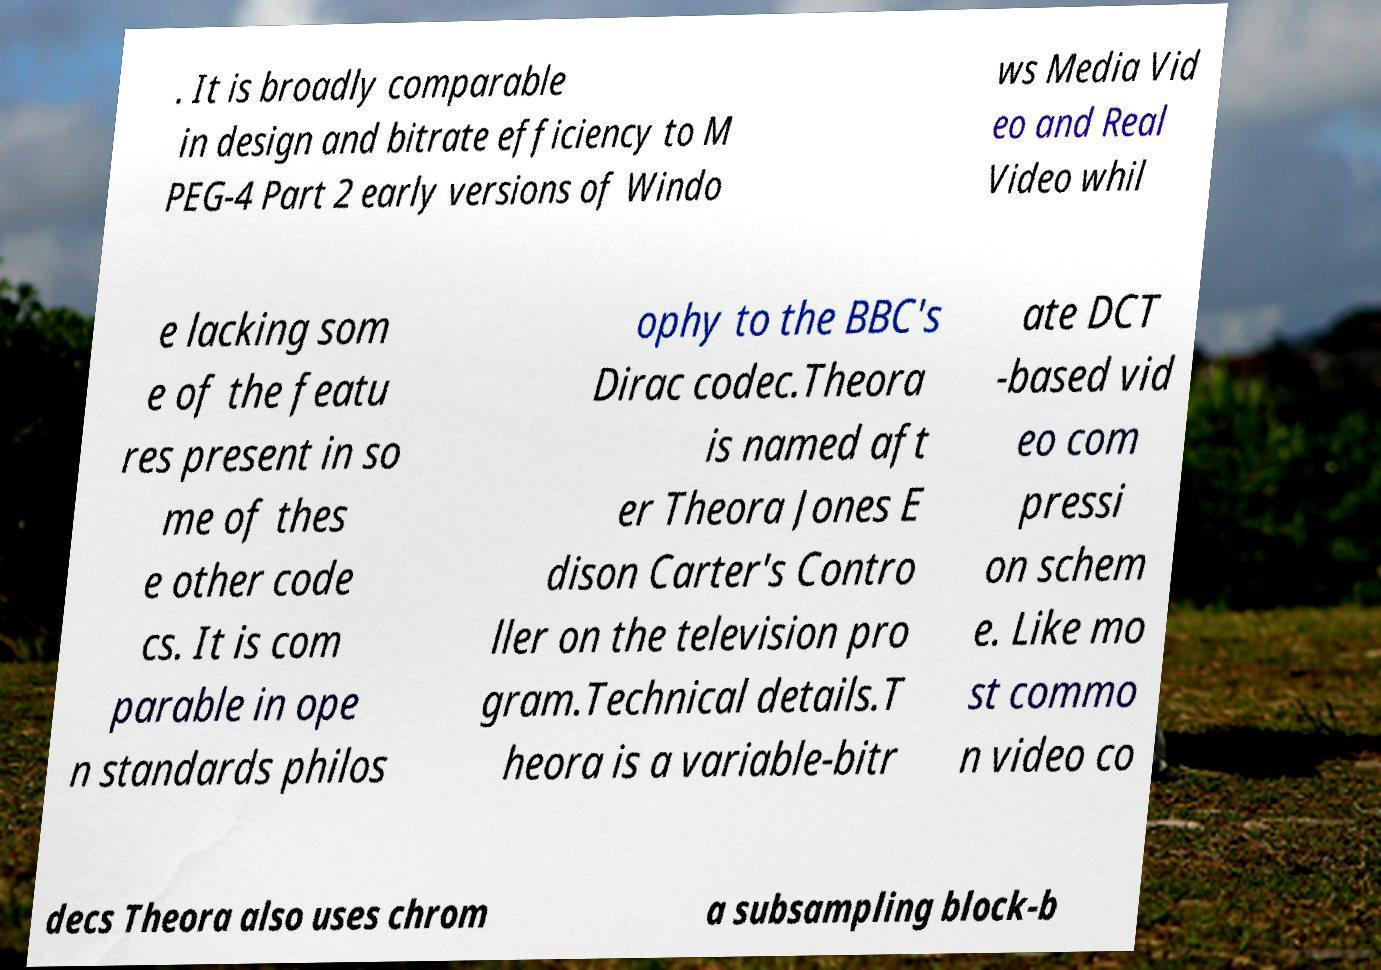I need the written content from this picture converted into text. Can you do that? . It is broadly comparable in design and bitrate efficiency to M PEG-4 Part 2 early versions of Windo ws Media Vid eo and Real Video whil e lacking som e of the featu res present in so me of thes e other code cs. It is com parable in ope n standards philos ophy to the BBC's Dirac codec.Theora is named aft er Theora Jones E dison Carter's Contro ller on the television pro gram.Technical details.T heora is a variable-bitr ate DCT -based vid eo com pressi on schem e. Like mo st commo n video co decs Theora also uses chrom a subsampling block-b 